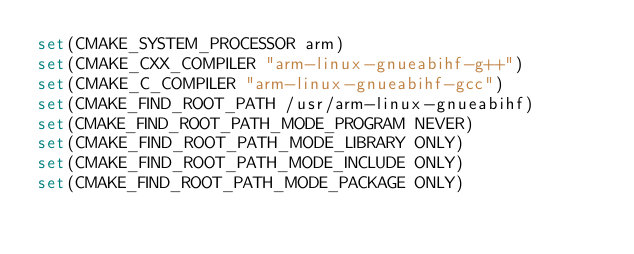<code> <loc_0><loc_0><loc_500><loc_500><_CMake_>set(CMAKE_SYSTEM_PROCESSOR arm)
set(CMAKE_CXX_COMPILER "arm-linux-gnueabihf-g++")
set(CMAKE_C_COMPILER "arm-linux-gnueabihf-gcc")
set(CMAKE_FIND_ROOT_PATH /usr/arm-linux-gnueabihf)
set(CMAKE_FIND_ROOT_PATH_MODE_PROGRAM NEVER)
set(CMAKE_FIND_ROOT_PATH_MODE_LIBRARY ONLY)
set(CMAKE_FIND_ROOT_PATH_MODE_INCLUDE ONLY)
set(CMAKE_FIND_ROOT_PATH_MODE_PACKAGE ONLY)
</code> 